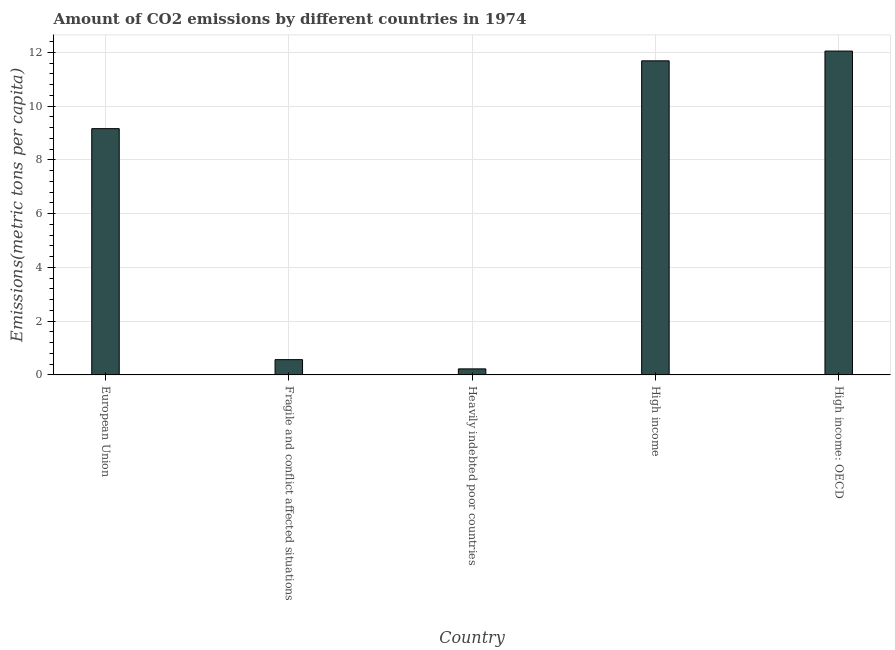Does the graph contain any zero values?
Your answer should be compact. No. What is the title of the graph?
Your answer should be compact. Amount of CO2 emissions by different countries in 1974. What is the label or title of the Y-axis?
Your response must be concise. Emissions(metric tons per capita). What is the amount of co2 emissions in High income: OECD?
Provide a short and direct response. 12.05. Across all countries, what is the maximum amount of co2 emissions?
Ensure brevity in your answer.  12.05. Across all countries, what is the minimum amount of co2 emissions?
Your answer should be compact. 0.22. In which country was the amount of co2 emissions maximum?
Offer a terse response. High income: OECD. In which country was the amount of co2 emissions minimum?
Offer a very short reply. Heavily indebted poor countries. What is the sum of the amount of co2 emissions?
Your response must be concise. 33.69. What is the difference between the amount of co2 emissions in Fragile and conflict affected situations and High income?
Keep it short and to the point. -11.12. What is the average amount of co2 emissions per country?
Keep it short and to the point. 6.74. What is the median amount of co2 emissions?
Your answer should be very brief. 9.16. What is the ratio of the amount of co2 emissions in Fragile and conflict affected situations to that in High income?
Give a very brief answer. 0.05. Is the amount of co2 emissions in High income less than that in High income: OECD?
Provide a succinct answer. Yes. Is the difference between the amount of co2 emissions in European Union and Fragile and conflict affected situations greater than the difference between any two countries?
Ensure brevity in your answer.  No. What is the difference between the highest and the second highest amount of co2 emissions?
Keep it short and to the point. 0.36. What is the difference between the highest and the lowest amount of co2 emissions?
Ensure brevity in your answer.  11.82. How many bars are there?
Provide a short and direct response. 5. Are all the bars in the graph horizontal?
Keep it short and to the point. No. How many countries are there in the graph?
Ensure brevity in your answer.  5. What is the difference between two consecutive major ticks on the Y-axis?
Your answer should be very brief. 2. What is the Emissions(metric tons per capita) of European Union?
Offer a terse response. 9.16. What is the Emissions(metric tons per capita) in Fragile and conflict affected situations?
Your answer should be compact. 0.57. What is the Emissions(metric tons per capita) of Heavily indebted poor countries?
Your answer should be very brief. 0.22. What is the Emissions(metric tons per capita) in High income?
Keep it short and to the point. 11.68. What is the Emissions(metric tons per capita) in High income: OECD?
Offer a very short reply. 12.05. What is the difference between the Emissions(metric tons per capita) in European Union and Fragile and conflict affected situations?
Provide a short and direct response. 8.59. What is the difference between the Emissions(metric tons per capita) in European Union and Heavily indebted poor countries?
Your answer should be very brief. 8.94. What is the difference between the Emissions(metric tons per capita) in European Union and High income?
Ensure brevity in your answer.  -2.52. What is the difference between the Emissions(metric tons per capita) in European Union and High income: OECD?
Keep it short and to the point. -2.89. What is the difference between the Emissions(metric tons per capita) in Fragile and conflict affected situations and Heavily indebted poor countries?
Offer a terse response. 0.34. What is the difference between the Emissions(metric tons per capita) in Fragile and conflict affected situations and High income?
Ensure brevity in your answer.  -11.12. What is the difference between the Emissions(metric tons per capita) in Fragile and conflict affected situations and High income: OECD?
Give a very brief answer. -11.48. What is the difference between the Emissions(metric tons per capita) in Heavily indebted poor countries and High income?
Give a very brief answer. -11.46. What is the difference between the Emissions(metric tons per capita) in Heavily indebted poor countries and High income: OECD?
Your response must be concise. -11.82. What is the difference between the Emissions(metric tons per capita) in High income and High income: OECD?
Your answer should be very brief. -0.36. What is the ratio of the Emissions(metric tons per capita) in European Union to that in Fragile and conflict affected situations?
Keep it short and to the point. 16.13. What is the ratio of the Emissions(metric tons per capita) in European Union to that in Heavily indebted poor countries?
Give a very brief answer. 40.88. What is the ratio of the Emissions(metric tons per capita) in European Union to that in High income?
Offer a terse response. 0.78. What is the ratio of the Emissions(metric tons per capita) in European Union to that in High income: OECD?
Keep it short and to the point. 0.76. What is the ratio of the Emissions(metric tons per capita) in Fragile and conflict affected situations to that in Heavily indebted poor countries?
Provide a succinct answer. 2.53. What is the ratio of the Emissions(metric tons per capita) in Fragile and conflict affected situations to that in High income?
Your answer should be compact. 0.05. What is the ratio of the Emissions(metric tons per capita) in Fragile and conflict affected situations to that in High income: OECD?
Ensure brevity in your answer.  0.05. What is the ratio of the Emissions(metric tons per capita) in Heavily indebted poor countries to that in High income?
Provide a succinct answer. 0.02. What is the ratio of the Emissions(metric tons per capita) in Heavily indebted poor countries to that in High income: OECD?
Make the answer very short. 0.02. What is the ratio of the Emissions(metric tons per capita) in High income to that in High income: OECD?
Your response must be concise. 0.97. 